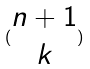Convert formula to latex. <formula><loc_0><loc_0><loc_500><loc_500>( \begin{matrix} n + 1 \\ k \end{matrix} )</formula> 